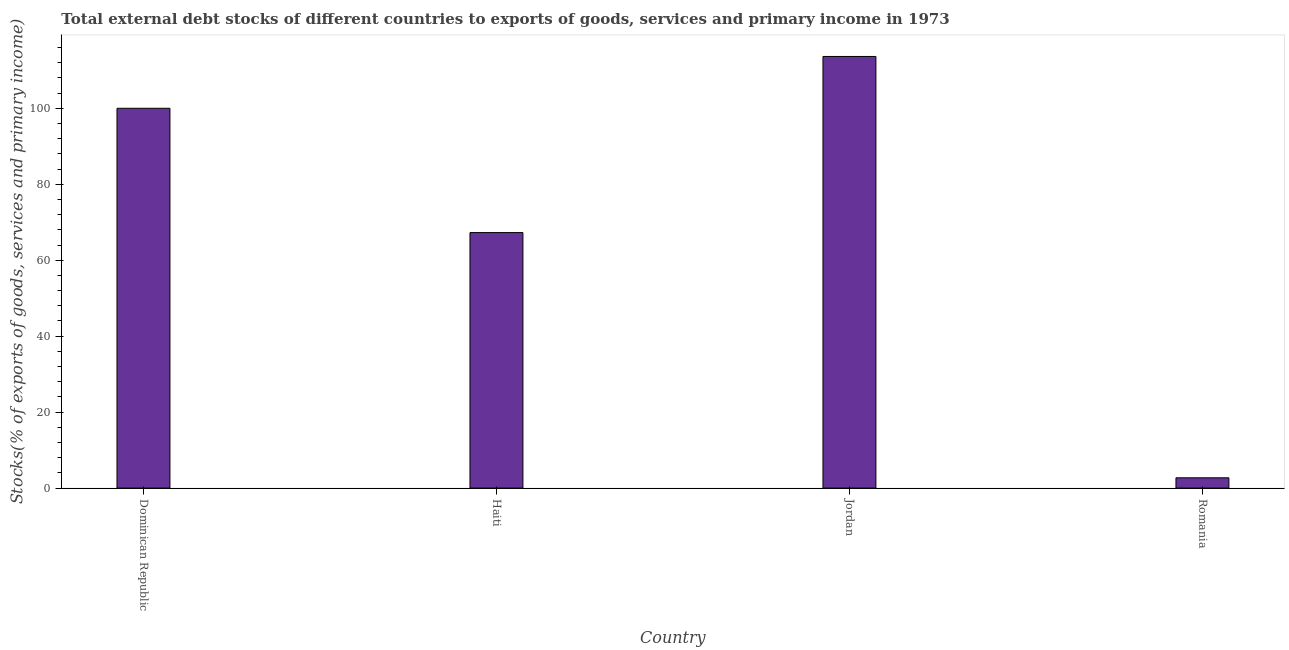Does the graph contain any zero values?
Offer a very short reply. No. What is the title of the graph?
Provide a short and direct response. Total external debt stocks of different countries to exports of goods, services and primary income in 1973. What is the label or title of the Y-axis?
Offer a very short reply. Stocks(% of exports of goods, services and primary income). What is the external debt stocks in Haiti?
Give a very brief answer. 67.28. Across all countries, what is the maximum external debt stocks?
Provide a short and direct response. 113.65. Across all countries, what is the minimum external debt stocks?
Keep it short and to the point. 2.71. In which country was the external debt stocks maximum?
Provide a short and direct response. Jordan. In which country was the external debt stocks minimum?
Your response must be concise. Romania. What is the sum of the external debt stocks?
Your answer should be compact. 283.64. What is the difference between the external debt stocks in Dominican Republic and Romania?
Make the answer very short. 97.29. What is the average external debt stocks per country?
Offer a terse response. 70.91. What is the median external debt stocks?
Your answer should be very brief. 83.64. What is the ratio of the external debt stocks in Dominican Republic to that in Jordan?
Your response must be concise. 0.88. Is the difference between the external debt stocks in Dominican Republic and Jordan greater than the difference between any two countries?
Your answer should be compact. No. What is the difference between the highest and the second highest external debt stocks?
Provide a short and direct response. 13.65. Is the sum of the external debt stocks in Jordan and Romania greater than the maximum external debt stocks across all countries?
Ensure brevity in your answer.  Yes. What is the difference between the highest and the lowest external debt stocks?
Give a very brief answer. 110.94. In how many countries, is the external debt stocks greater than the average external debt stocks taken over all countries?
Your answer should be compact. 2. Are all the bars in the graph horizontal?
Offer a very short reply. No. Are the values on the major ticks of Y-axis written in scientific E-notation?
Your answer should be very brief. No. What is the Stocks(% of exports of goods, services and primary income) in Dominican Republic?
Give a very brief answer. 100. What is the Stocks(% of exports of goods, services and primary income) in Haiti?
Provide a short and direct response. 67.28. What is the Stocks(% of exports of goods, services and primary income) of Jordan?
Keep it short and to the point. 113.65. What is the Stocks(% of exports of goods, services and primary income) in Romania?
Your answer should be very brief. 2.71. What is the difference between the Stocks(% of exports of goods, services and primary income) in Dominican Republic and Haiti?
Ensure brevity in your answer.  32.73. What is the difference between the Stocks(% of exports of goods, services and primary income) in Dominican Republic and Jordan?
Make the answer very short. -13.65. What is the difference between the Stocks(% of exports of goods, services and primary income) in Dominican Republic and Romania?
Make the answer very short. 97.29. What is the difference between the Stocks(% of exports of goods, services and primary income) in Haiti and Jordan?
Your response must be concise. -46.38. What is the difference between the Stocks(% of exports of goods, services and primary income) in Haiti and Romania?
Provide a short and direct response. 64.57. What is the difference between the Stocks(% of exports of goods, services and primary income) in Jordan and Romania?
Keep it short and to the point. 110.94. What is the ratio of the Stocks(% of exports of goods, services and primary income) in Dominican Republic to that in Haiti?
Provide a succinct answer. 1.49. What is the ratio of the Stocks(% of exports of goods, services and primary income) in Dominican Republic to that in Jordan?
Provide a short and direct response. 0.88. What is the ratio of the Stocks(% of exports of goods, services and primary income) in Dominican Republic to that in Romania?
Offer a very short reply. 36.92. What is the ratio of the Stocks(% of exports of goods, services and primary income) in Haiti to that in Jordan?
Your answer should be compact. 0.59. What is the ratio of the Stocks(% of exports of goods, services and primary income) in Haiti to that in Romania?
Your answer should be very brief. 24.84. What is the ratio of the Stocks(% of exports of goods, services and primary income) in Jordan to that in Romania?
Offer a terse response. 41.96. 